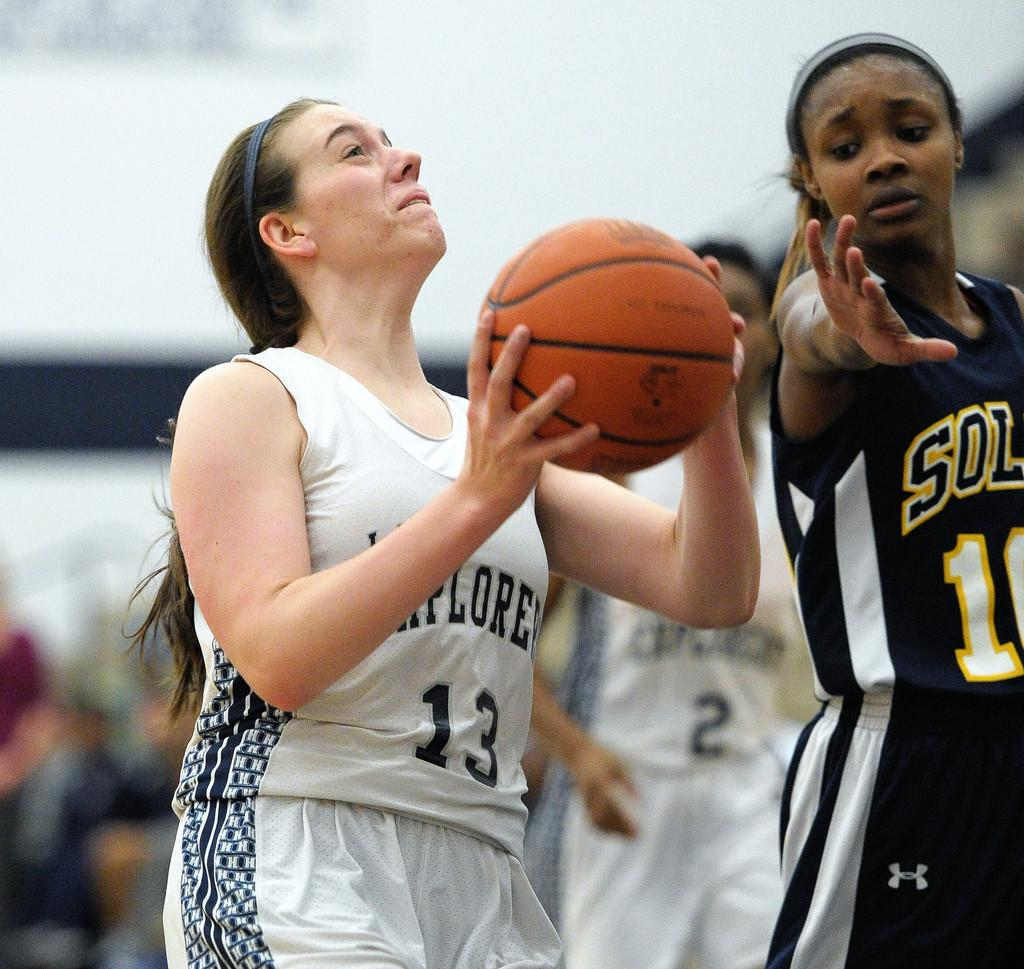<image>
Create a compact narrative representing the image presented. Women are playing the game of basketball on a court 